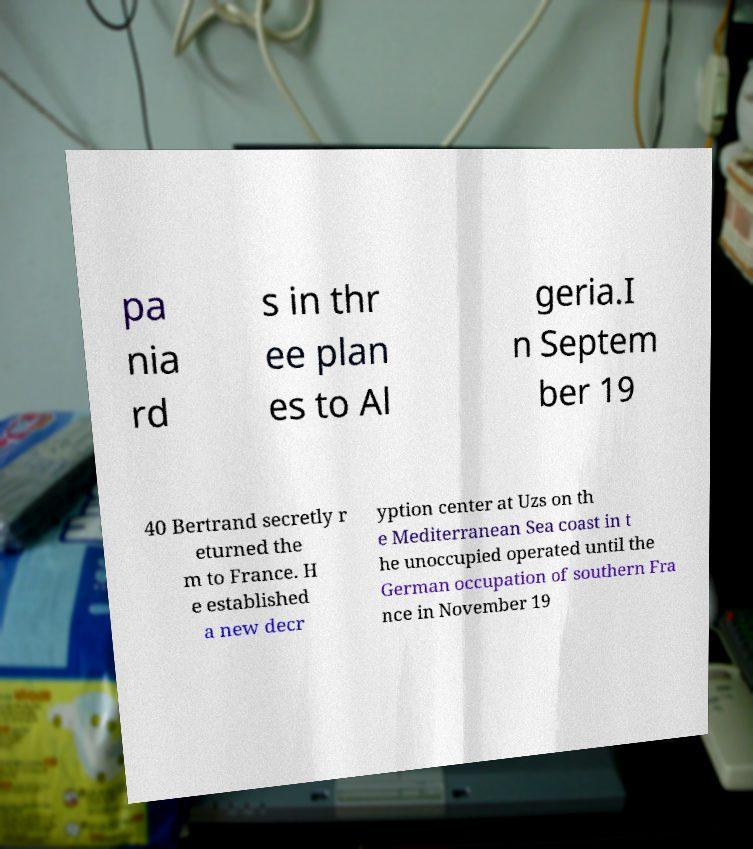There's text embedded in this image that I need extracted. Can you transcribe it verbatim? pa nia rd s in thr ee plan es to Al geria.I n Septem ber 19 40 Bertrand secretly r eturned the m to France. H e established a new decr yption center at Uzs on th e Mediterranean Sea coast in t he unoccupied operated until the German occupation of southern Fra nce in November 19 